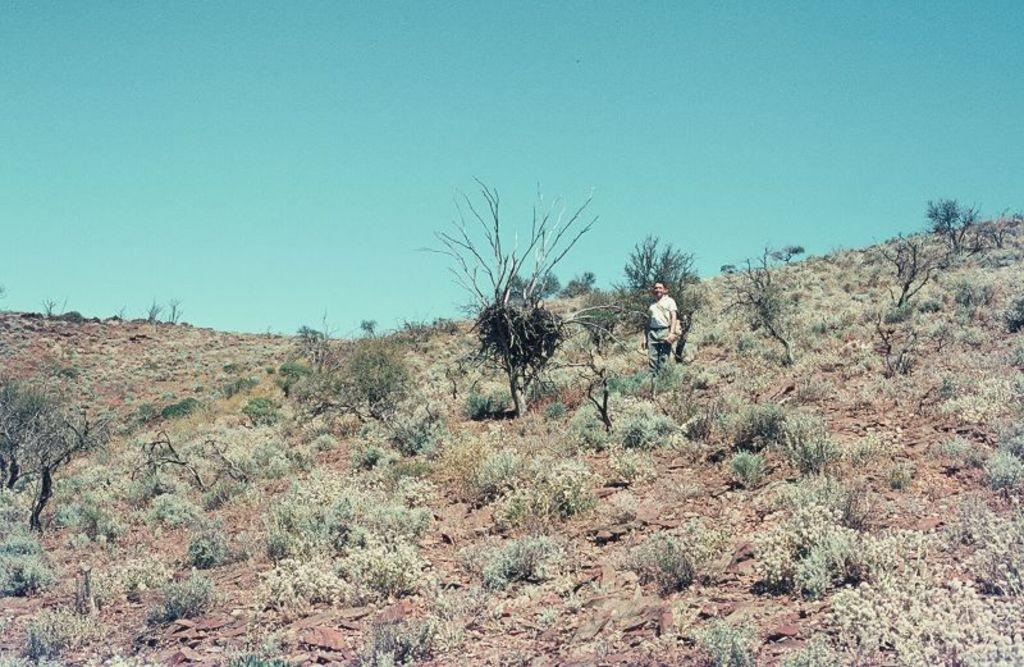What is the main subject of the image? There is a person in the image. What other elements can be seen in the image? There are plants and trees in the image. What can be seen in the background of the image? The sky is visible in the background of the image. What type of pie is being cooked on the stove in the image? There is no pie or stove present in the image. 